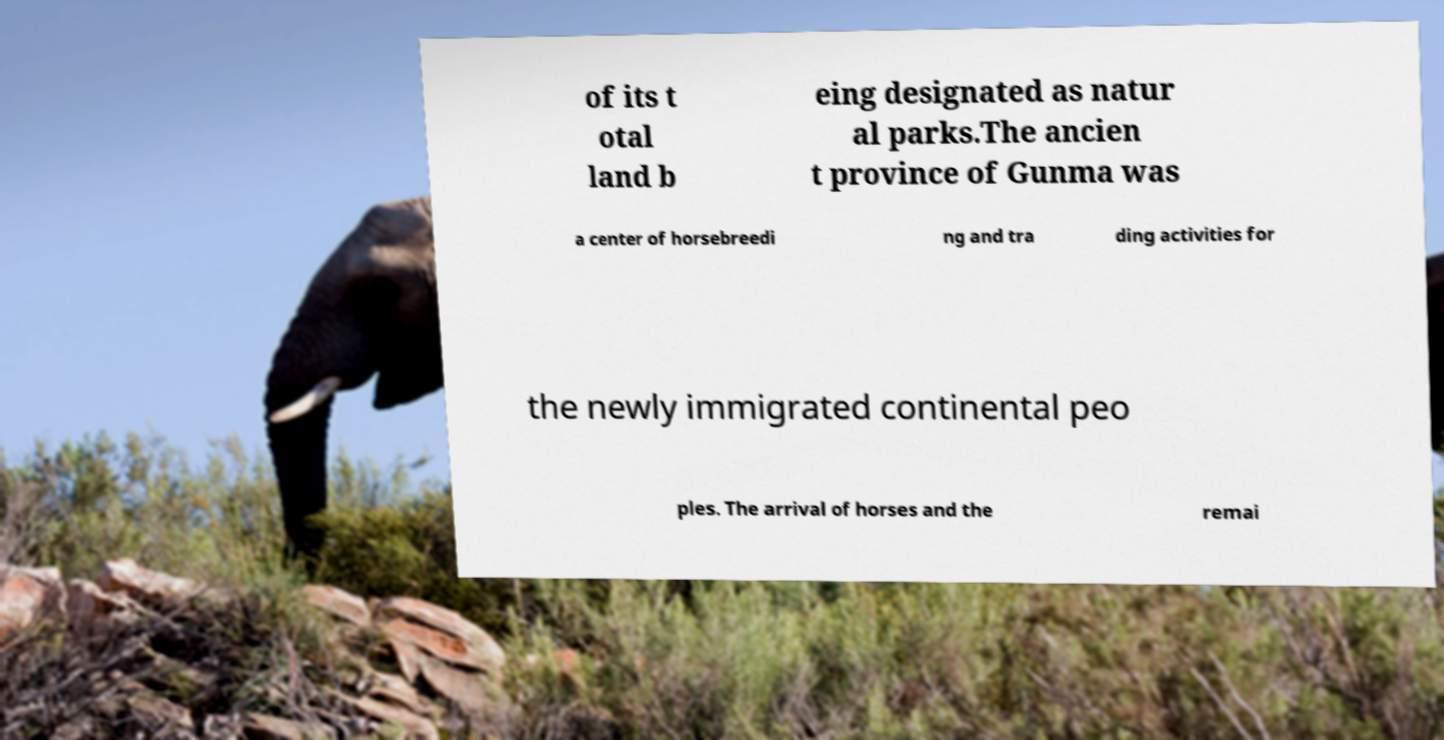Can you read and provide the text displayed in the image?This photo seems to have some interesting text. Can you extract and type it out for me? of its t otal land b eing designated as natur al parks.The ancien t province of Gunma was a center of horsebreedi ng and tra ding activities for the newly immigrated continental peo ples. The arrival of horses and the remai 